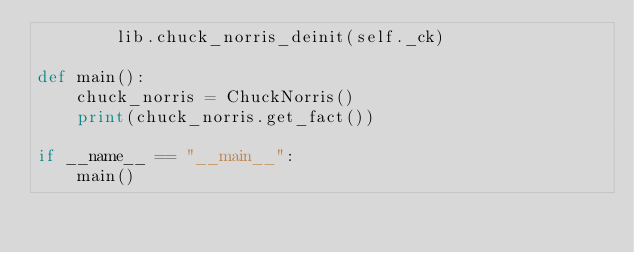Convert code to text. <code><loc_0><loc_0><loc_500><loc_500><_Python_>        lib.chuck_norris_deinit(self._ck)

def main():
    chuck_norris = ChuckNorris()
    print(chuck_norris.get_fact())

if __name__ == "__main__":
    main()</code> 